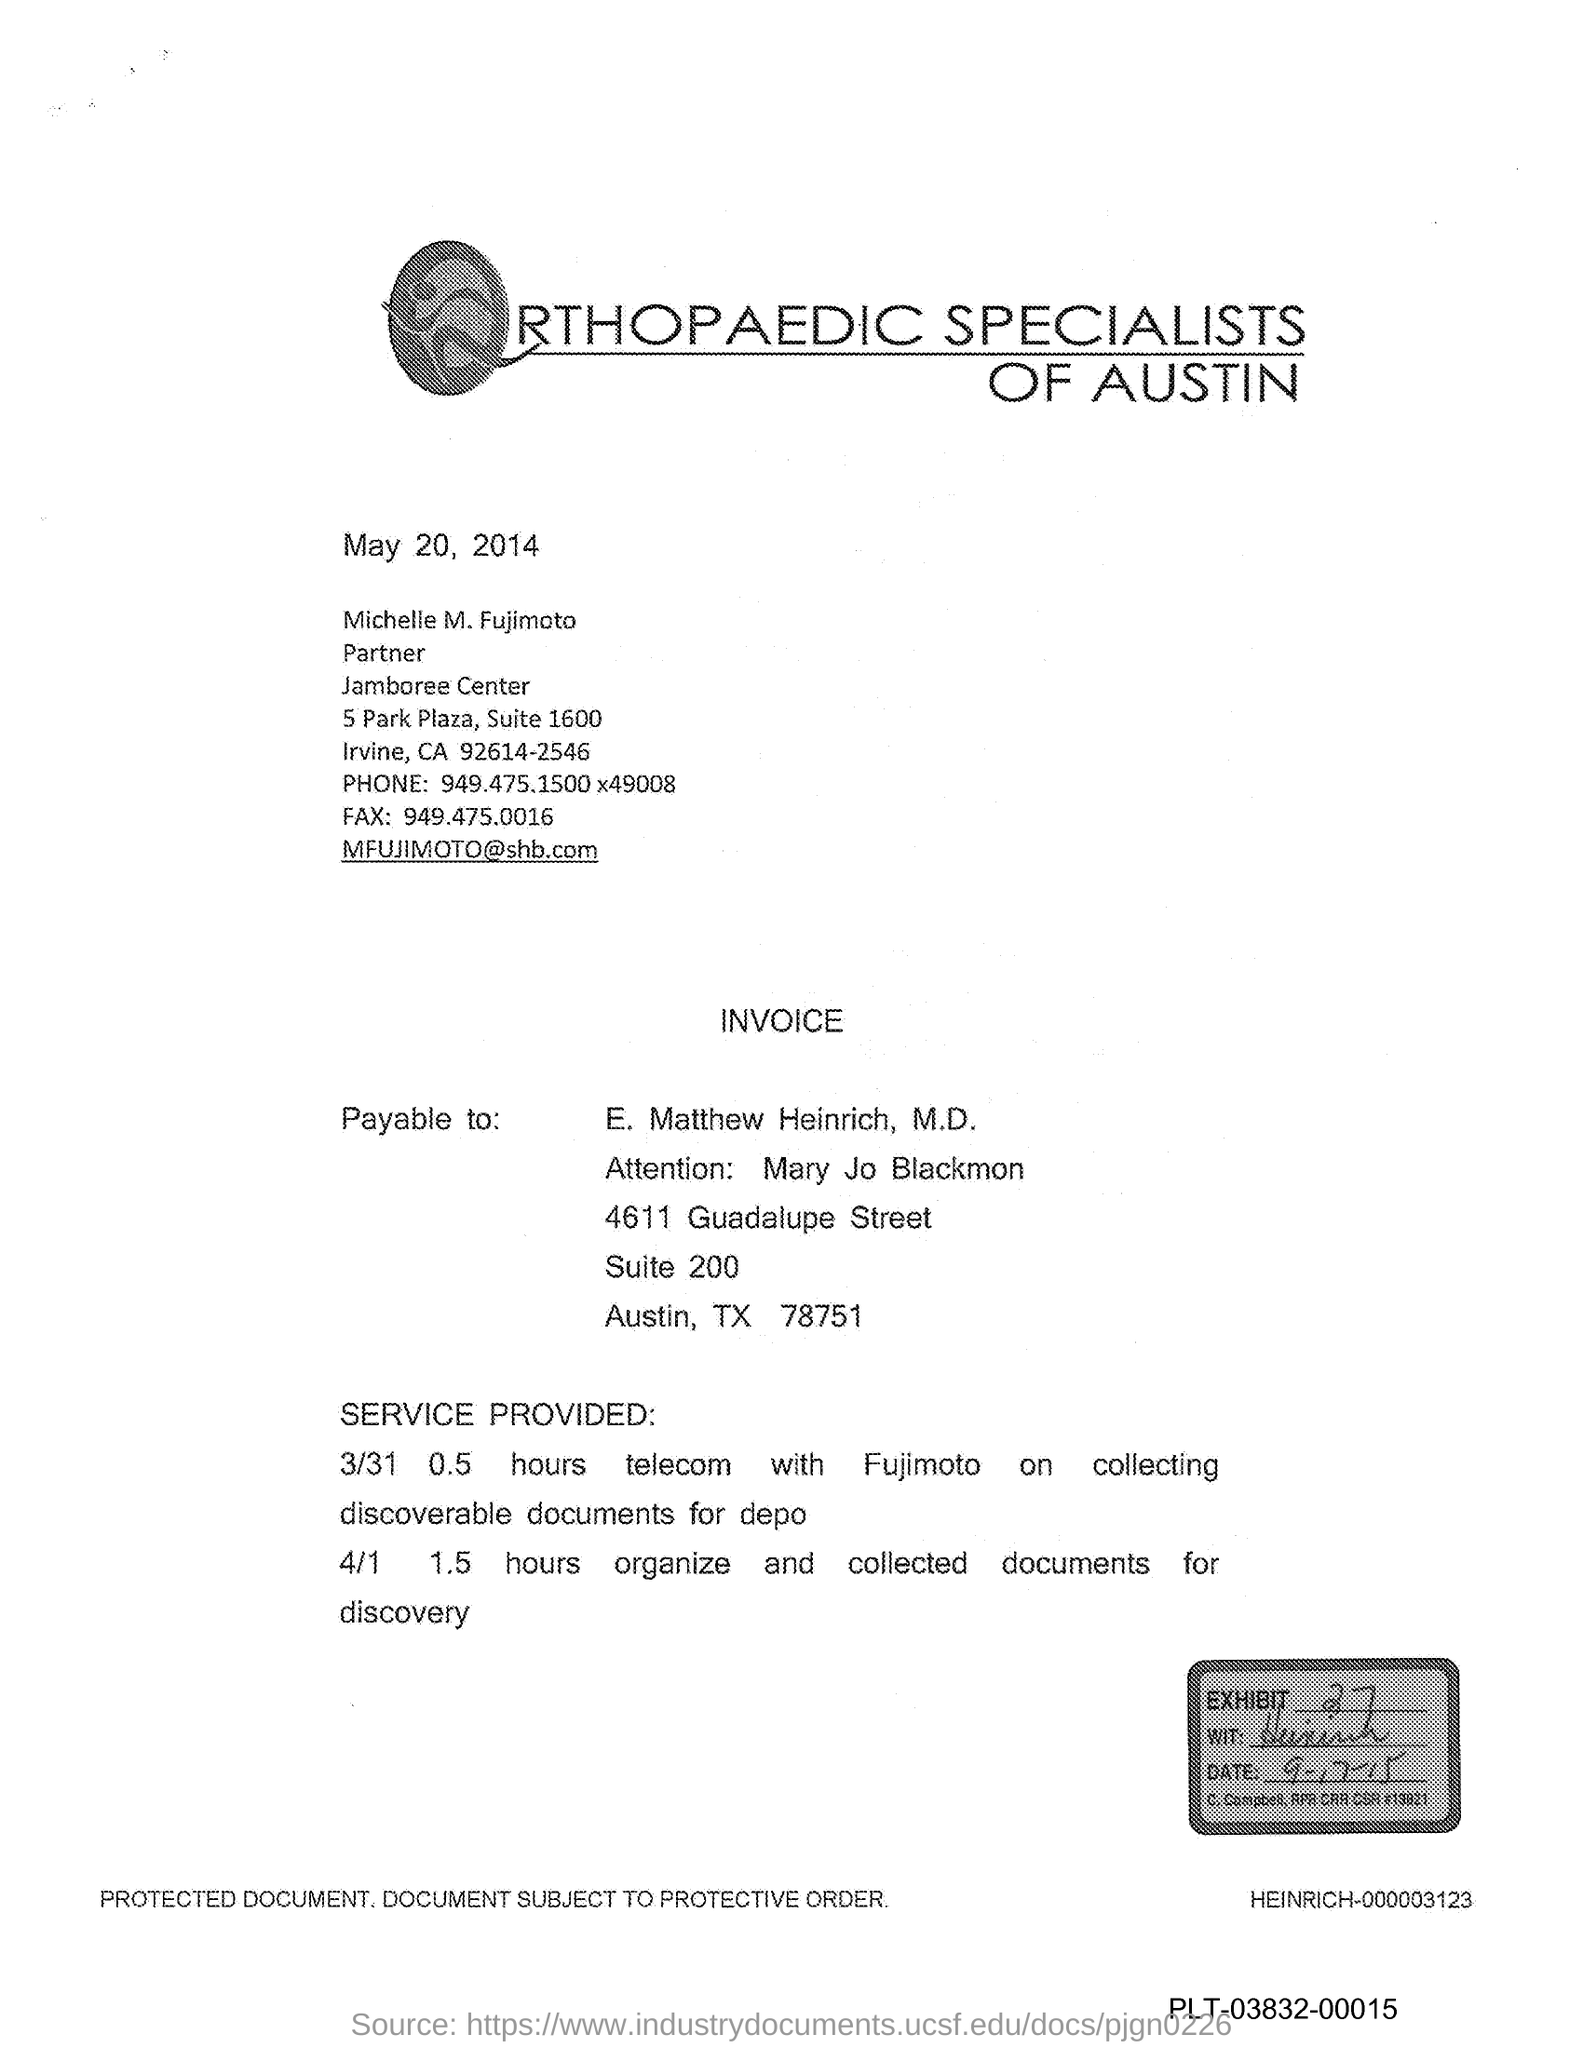Specify some key components in this picture. The fax number is 949.475.0016. The exhibit number is 27. 